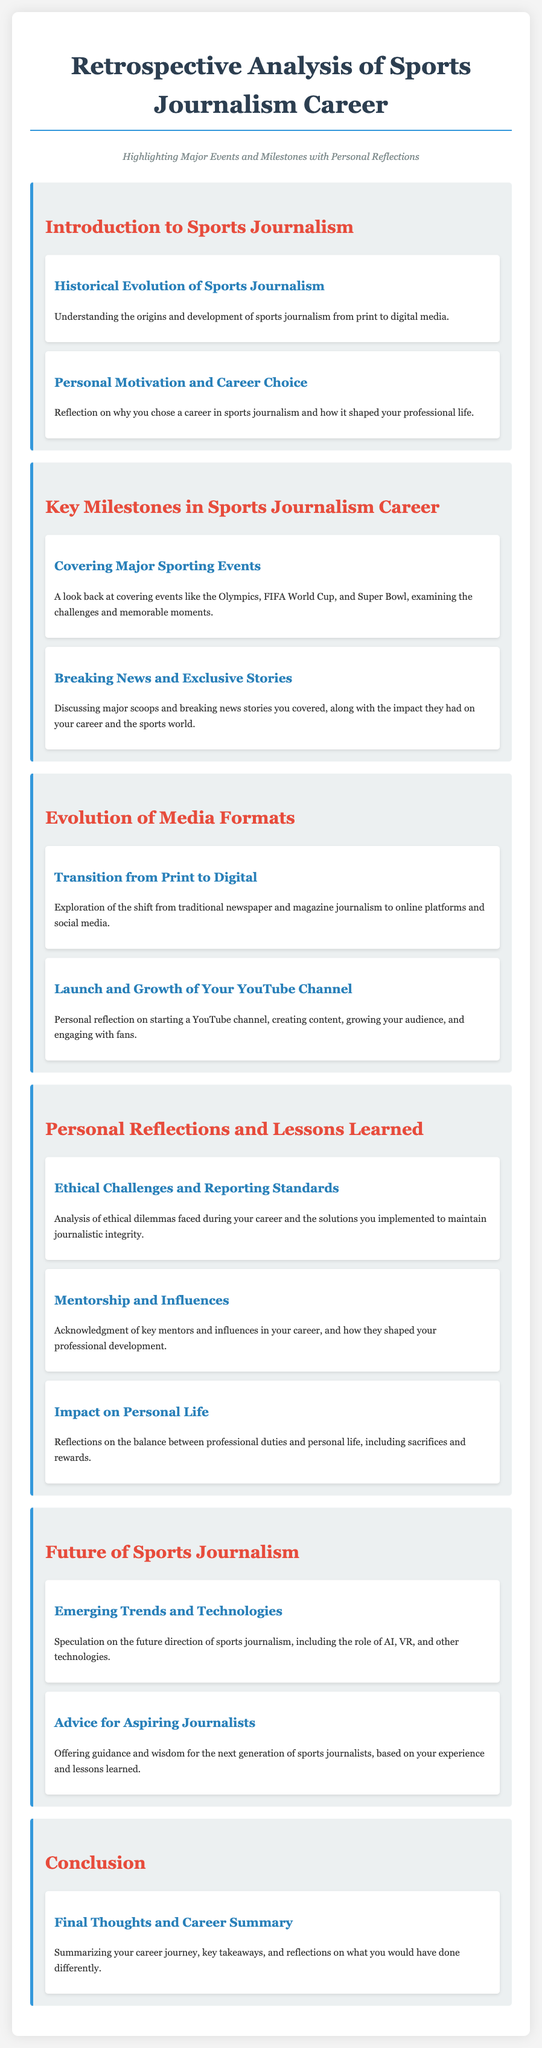What is the title of the document? The title is prominently displayed at the top of the document, stating the focus on retrospective analysis of a sports journalism career.
Answer: Retrospective Analysis of Sports Journalism Career What is the first module of the syllabus? The first module introduces the basic concepts and historical context of sports journalism, as outlined in the document.
Answer: Introduction to Sports Journalism Which major sporting events are mentioned in the second module? The document lists significant events that have been covered in the author's career to highlight key milestones.
Answer: Olympics, FIFA World Cup, Super Bowl What type of media transition is discussed in the third module? The document explores crucial changes in the media landscape that have influenced sports journalism.
Answer: Transition from Print to Digital What does the final topic in the conclusion module focus on? The last section summarizes the entire career journey and personal reflections, concluding the syllabus.
Answer: Final Thoughts and Career Summary Who does the author acknowledge in the personal reflections module? This section emphasizes the importance of guidance and support received throughout the author's career.
Answer: Mentorship and Influences 